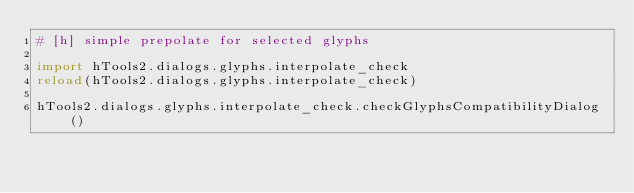Convert code to text. <code><loc_0><loc_0><loc_500><loc_500><_Python_># [h] simple prepolate for selected glyphs

import hTools2.dialogs.glyphs.interpolate_check
reload(hTools2.dialogs.glyphs.interpolate_check)

hTools2.dialogs.glyphs.interpolate_check.checkGlyphsCompatibilityDialog()
</code> 